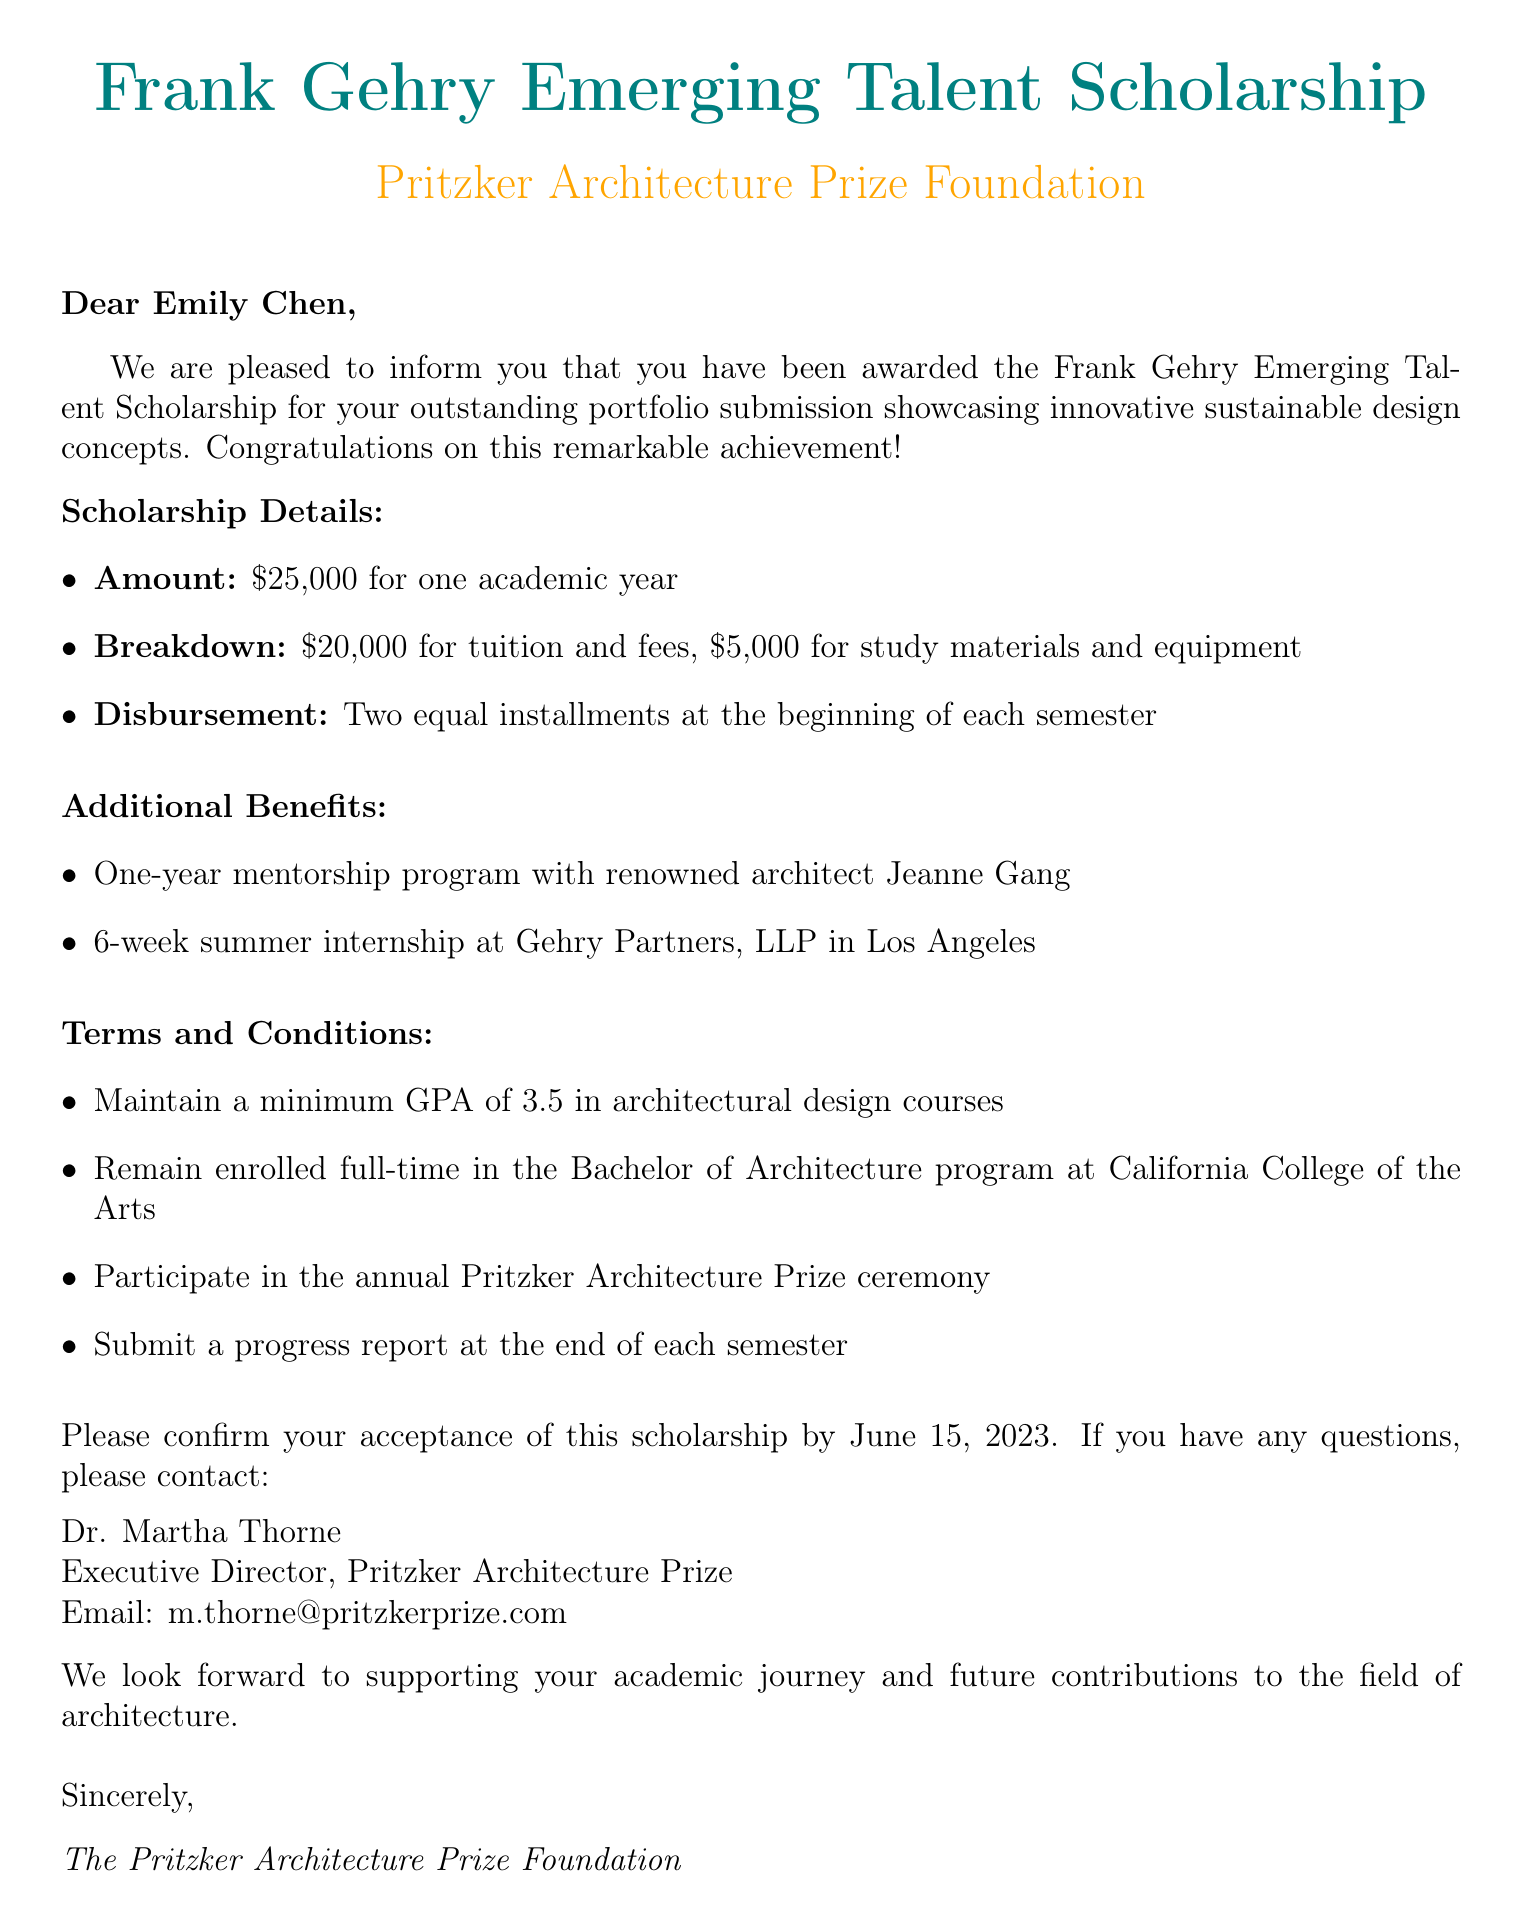What is the name of the scholarship? The scholarship awarded is specifically named in the document.
Answer: Frank Gehry Emerging Talent Scholarship What is the grant amount? The document states the total scholarship amount clearly.
Answer: $25,000 What is the duration of the scholarship? The document specifies how long the scholarship will last.
Answer: One academic year Who is the contact person for further questions? The document provides a name for whom to contact regarding the scholarship.
Answer: Dr. Martha Thorne What is the minimum GPA requirement? The document mentions the GPA that must be maintained.
Answer: 3.5 What internship opportunity is included? The document outlines the internship that is part of the scholarship benefits.
Answer: 6-week summer internship at Gehry Partners, LLP When is the acceptance deadline? The document specifies a date by which acceptance must be confirmed.
Answer: June 15, 2023 What is the total amount allocated for tuition and fees? The document breaks down the scholarship amount, indicating how much is for tuition.
Answer: $20,000 What is the mentorship program duration? The document describes the length of the mentorship advantage provided.
Answer: One year 